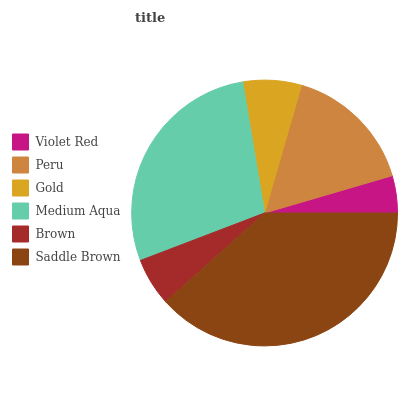Is Violet Red the minimum?
Answer yes or no. Yes. Is Saddle Brown the maximum?
Answer yes or no. Yes. Is Peru the minimum?
Answer yes or no. No. Is Peru the maximum?
Answer yes or no. No. Is Peru greater than Violet Red?
Answer yes or no. Yes. Is Violet Red less than Peru?
Answer yes or no. Yes. Is Violet Red greater than Peru?
Answer yes or no. No. Is Peru less than Violet Red?
Answer yes or no. No. Is Peru the high median?
Answer yes or no. Yes. Is Gold the low median?
Answer yes or no. Yes. Is Saddle Brown the high median?
Answer yes or no. No. Is Brown the low median?
Answer yes or no. No. 